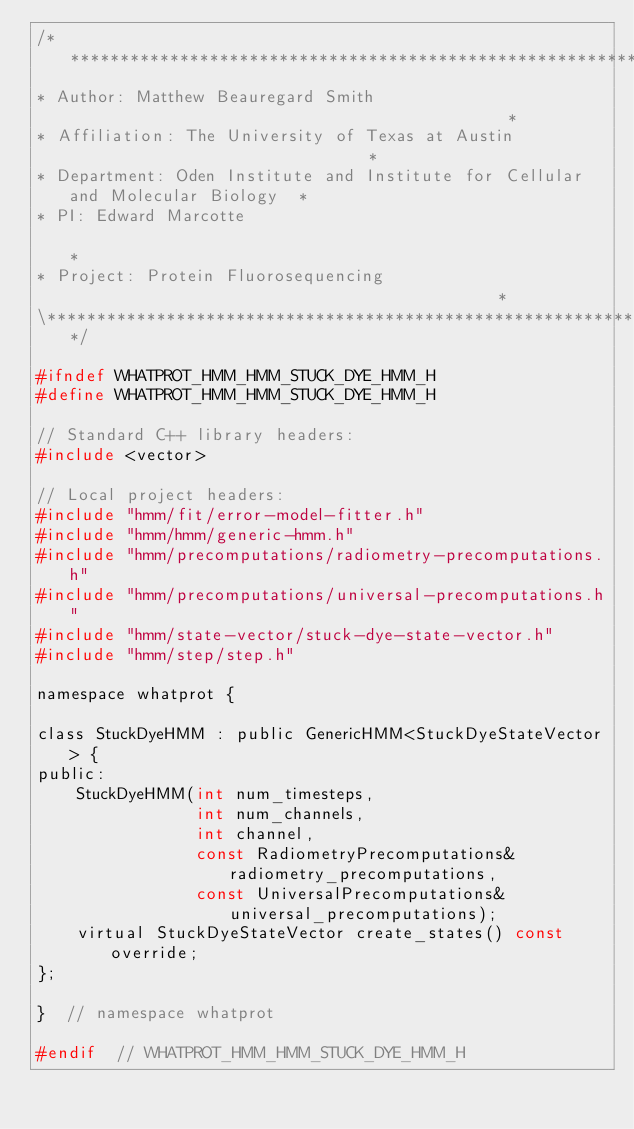Convert code to text. <code><loc_0><loc_0><loc_500><loc_500><_C_>/******************************************************************************\
* Author: Matthew Beauregard Smith                                             *
* Affiliation: The University of Texas at Austin                               *
* Department: Oden Institute and Institute for Cellular and Molecular Biology  *
* PI: Edward Marcotte                                                          *
* Project: Protein Fluorosequencing                                            *
\******************************************************************************/

#ifndef WHATPROT_HMM_HMM_STUCK_DYE_HMM_H
#define WHATPROT_HMM_HMM_STUCK_DYE_HMM_H

// Standard C++ library headers:
#include <vector>

// Local project headers:
#include "hmm/fit/error-model-fitter.h"
#include "hmm/hmm/generic-hmm.h"
#include "hmm/precomputations/radiometry-precomputations.h"
#include "hmm/precomputations/universal-precomputations.h"
#include "hmm/state-vector/stuck-dye-state-vector.h"
#include "hmm/step/step.h"

namespace whatprot {

class StuckDyeHMM : public GenericHMM<StuckDyeStateVector> {
public:
    StuckDyeHMM(int num_timesteps,
                int num_channels,
                int channel,
                const RadiometryPrecomputations& radiometry_precomputations,
                const UniversalPrecomputations& universal_precomputations);
    virtual StuckDyeStateVector create_states() const override;
};

}  // namespace whatprot

#endif  // WHATPROT_HMM_HMM_STUCK_DYE_HMM_H
</code> 